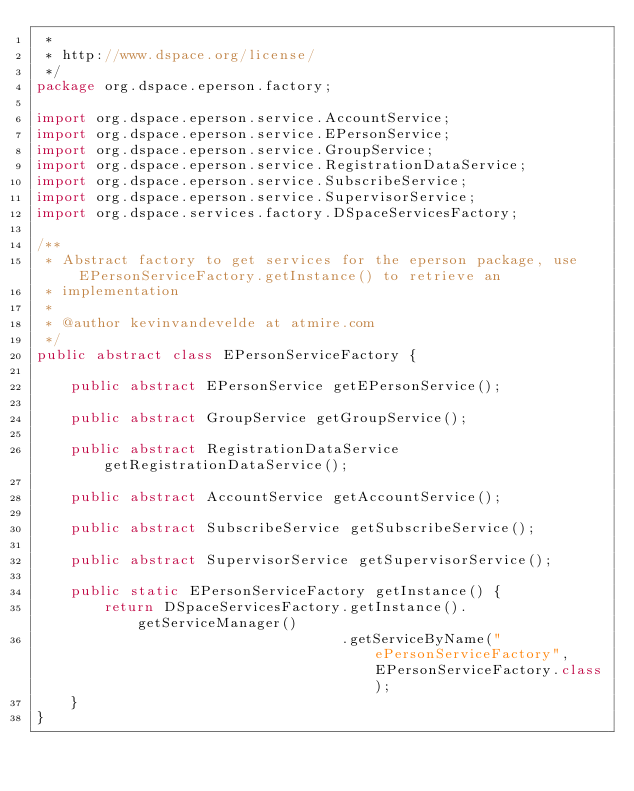Convert code to text. <code><loc_0><loc_0><loc_500><loc_500><_Java_> *
 * http://www.dspace.org/license/
 */
package org.dspace.eperson.factory;

import org.dspace.eperson.service.AccountService;
import org.dspace.eperson.service.EPersonService;
import org.dspace.eperson.service.GroupService;
import org.dspace.eperson.service.RegistrationDataService;
import org.dspace.eperson.service.SubscribeService;
import org.dspace.eperson.service.SupervisorService;
import org.dspace.services.factory.DSpaceServicesFactory;

/**
 * Abstract factory to get services for the eperson package, use EPersonServiceFactory.getInstance() to retrieve an
 * implementation
 *
 * @author kevinvandevelde at atmire.com
 */
public abstract class EPersonServiceFactory {

    public abstract EPersonService getEPersonService();

    public abstract GroupService getGroupService();

    public abstract RegistrationDataService getRegistrationDataService();

    public abstract AccountService getAccountService();

    public abstract SubscribeService getSubscribeService();

    public abstract SupervisorService getSupervisorService();

    public static EPersonServiceFactory getInstance() {
        return DSpaceServicesFactory.getInstance().getServiceManager()
                                    .getServiceByName("ePersonServiceFactory", EPersonServiceFactory.class);
    }
}
</code> 